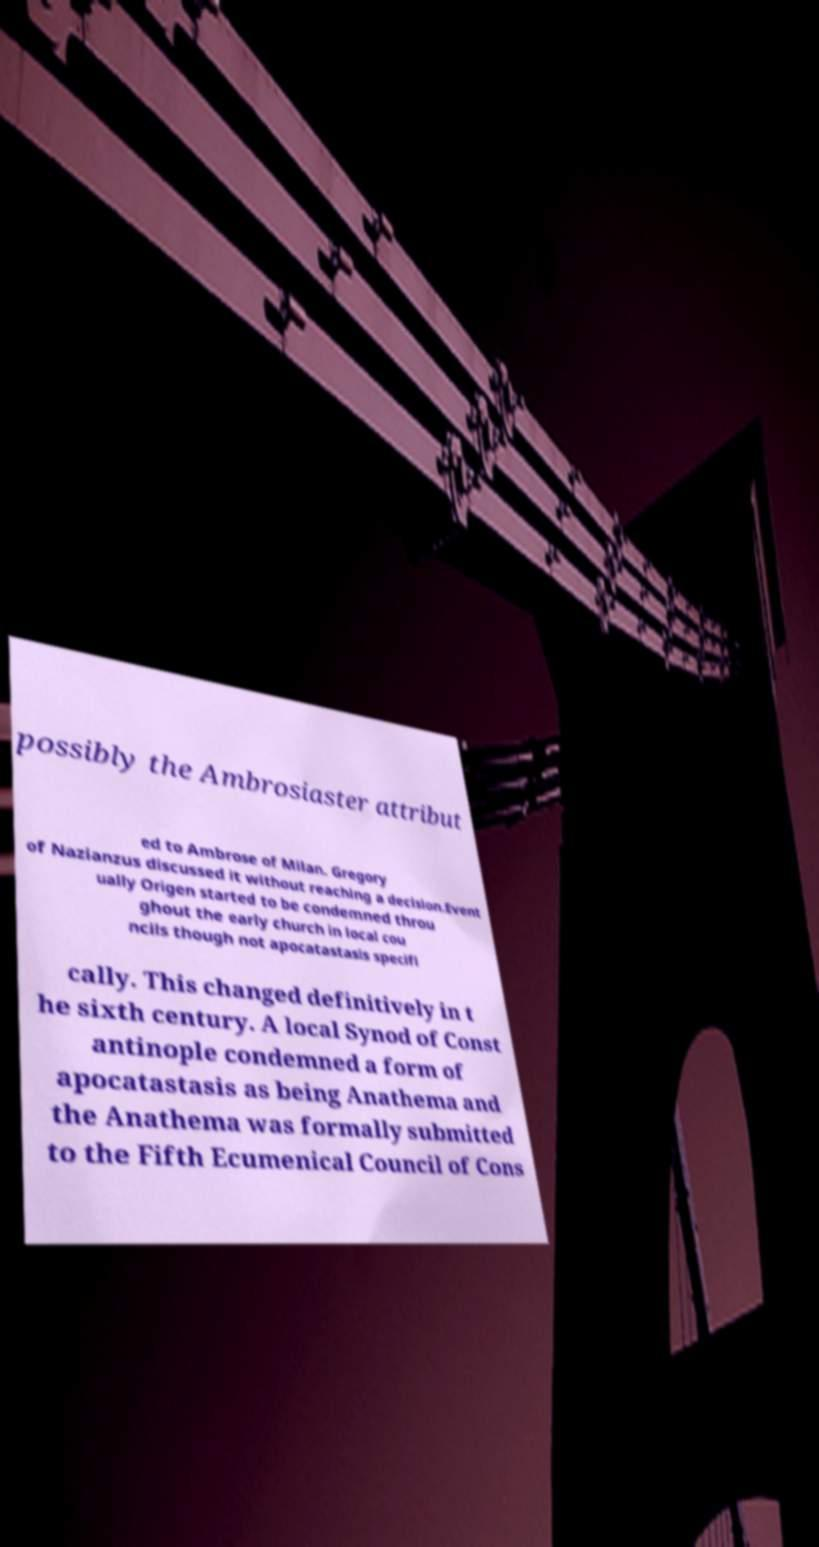Can you accurately transcribe the text from the provided image for me? possibly the Ambrosiaster attribut ed to Ambrose of Milan. Gregory of Nazianzus discussed it without reaching a decision.Event ually Origen started to be condemned throu ghout the early church in local cou ncils though not apocatastasis specifi cally. This changed definitively in t he sixth century. A local Synod of Const antinople condemned a form of apocatastasis as being Anathema and the Anathema was formally submitted to the Fifth Ecumenical Council of Cons 